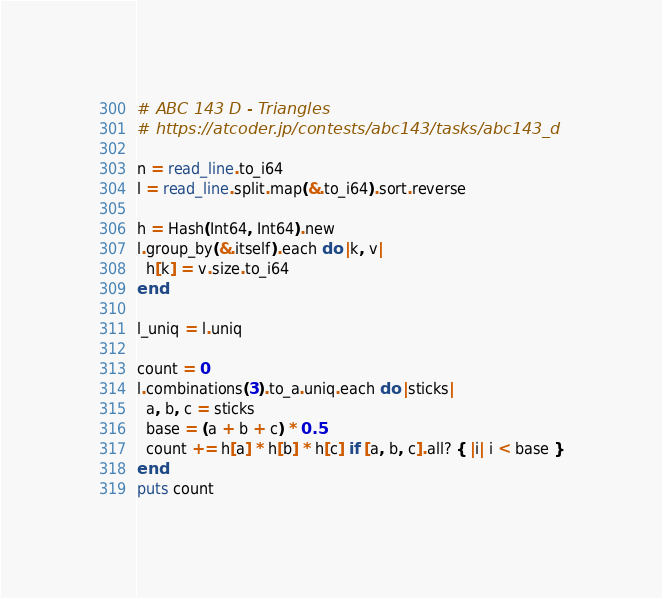<code> <loc_0><loc_0><loc_500><loc_500><_Crystal_># ABC 143 D - Triangles
# https://atcoder.jp/contests/abc143/tasks/abc143_d

n = read_line.to_i64
l = read_line.split.map(&.to_i64).sort.reverse

h = Hash(Int64, Int64).new
l.group_by(&.itself).each do |k, v|
  h[k] = v.size.to_i64
end

l_uniq = l.uniq

count = 0
l.combinations(3).to_a.uniq.each do |sticks|
  a, b, c = sticks
  base = (a + b + c) * 0.5
  count += h[a] * h[b] * h[c] if [a, b, c].all? { |i| i < base }
end
puts count
</code> 